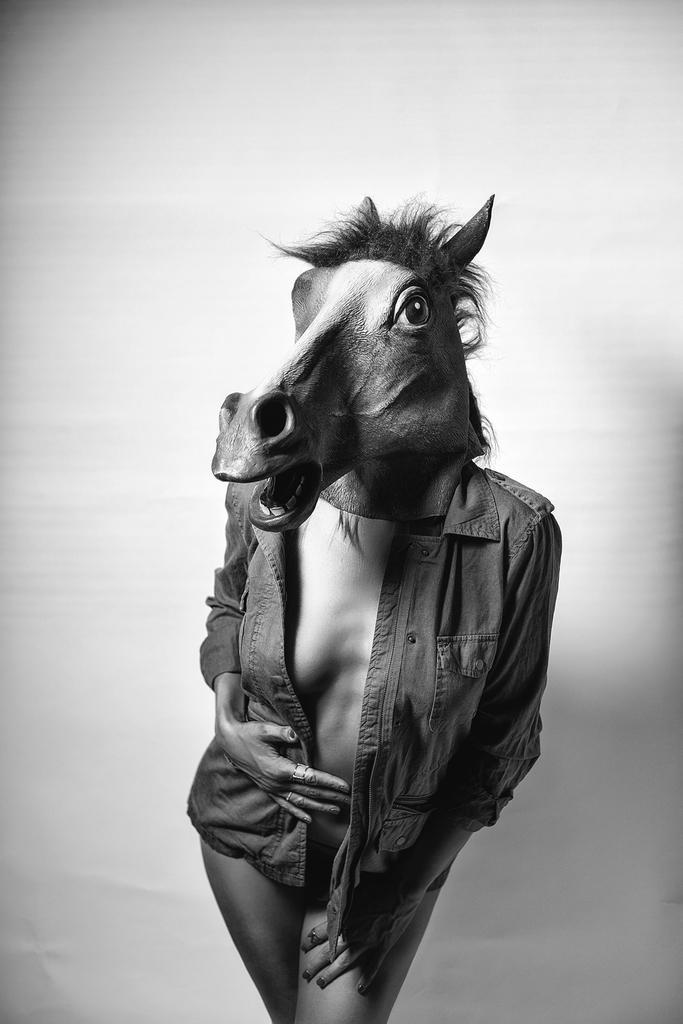How would you summarize this image in a sentence or two? This is a black and white picture. In this picture the women is wearing a jacket and also a animal mask and also the women have a ring to her finger. 